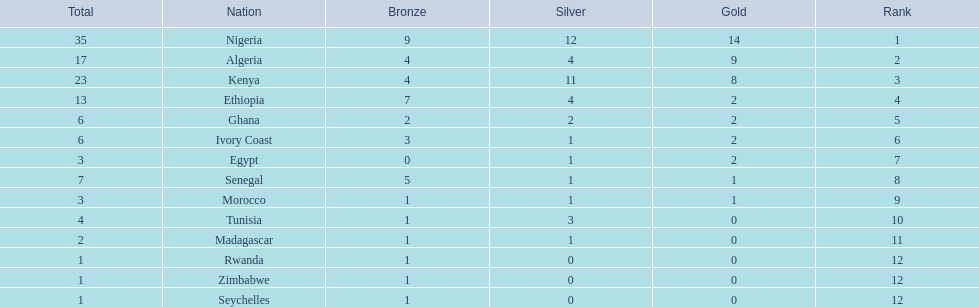Which country achieved the highest number of medals? Nigeria. 